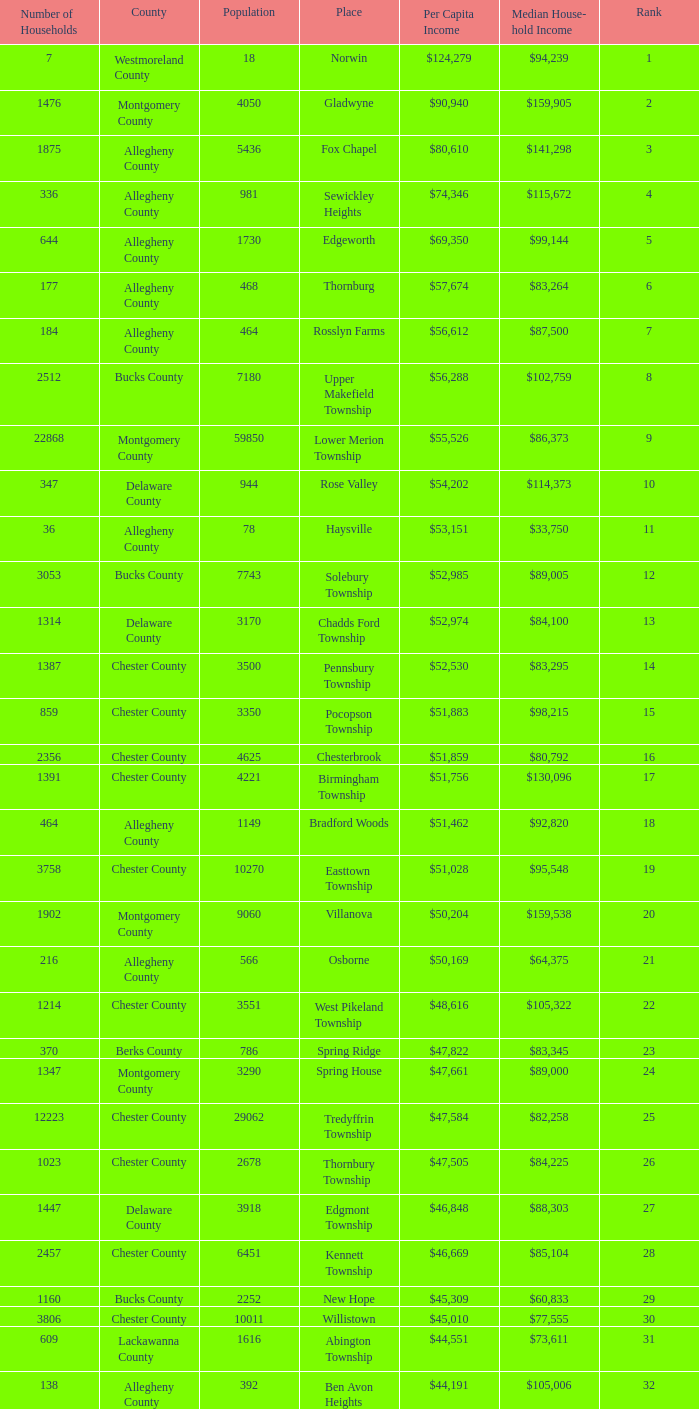Which county has a median household income of  $98,090? Bucks County. 